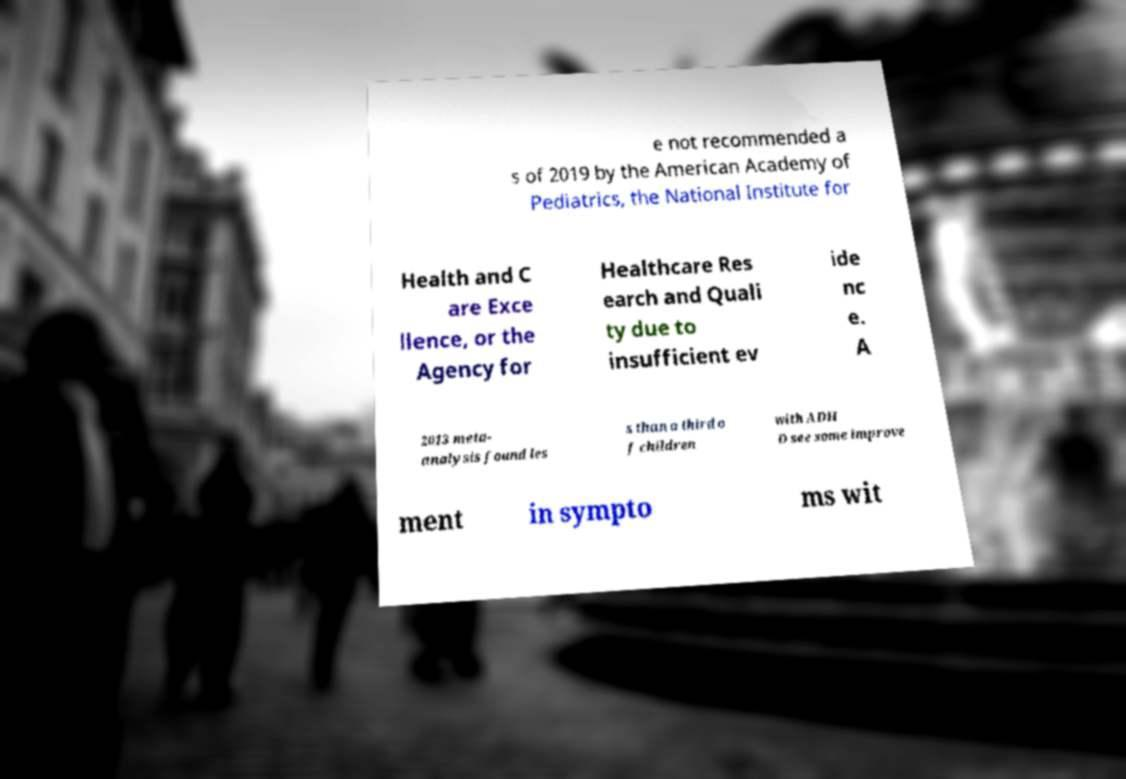Can you accurately transcribe the text from the provided image for me? e not recommended a s of 2019 by the American Academy of Pediatrics, the National Institute for Health and C are Exce llence, or the Agency for Healthcare Res earch and Quali ty due to insufficient ev ide nc e. A 2013 meta- analysis found les s than a third o f children with ADH D see some improve ment in sympto ms wit 